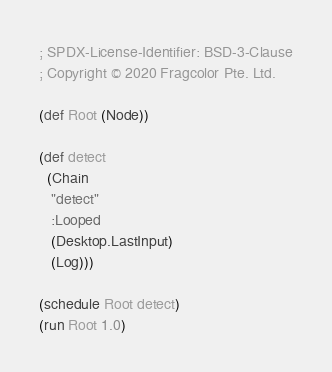<code> <loc_0><loc_0><loc_500><loc_500><_Clojure_>; SPDX-License-Identifier: BSD-3-Clause
; Copyright © 2020 Fragcolor Pte. Ltd.

(def Root (Node))

(def detect
  (Chain
   "detect"
   :Looped
   (Desktop.LastInput)
   (Log)))

(schedule Root detect)
(run Root 1.0)</code> 